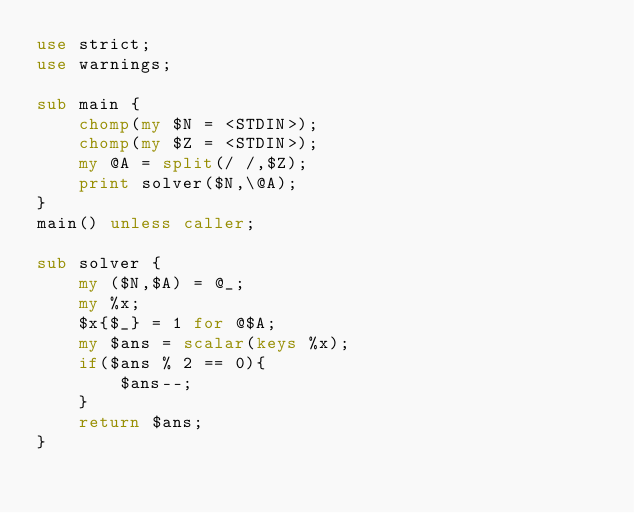<code> <loc_0><loc_0><loc_500><loc_500><_Perl_>use strict;
use warnings;

sub main {
    chomp(my $N = <STDIN>);
    chomp(my $Z = <STDIN>);
    my @A = split(/ /,$Z);
    print solver($N,\@A);
}
main() unless caller;

sub solver {
    my ($N,$A) = @_;
    my %x;
    $x{$_} = 1 for @$A;
    my $ans = scalar(keys %x);
    if($ans % 2 == 0){
        $ans--;
    }
    return $ans;
}</code> 